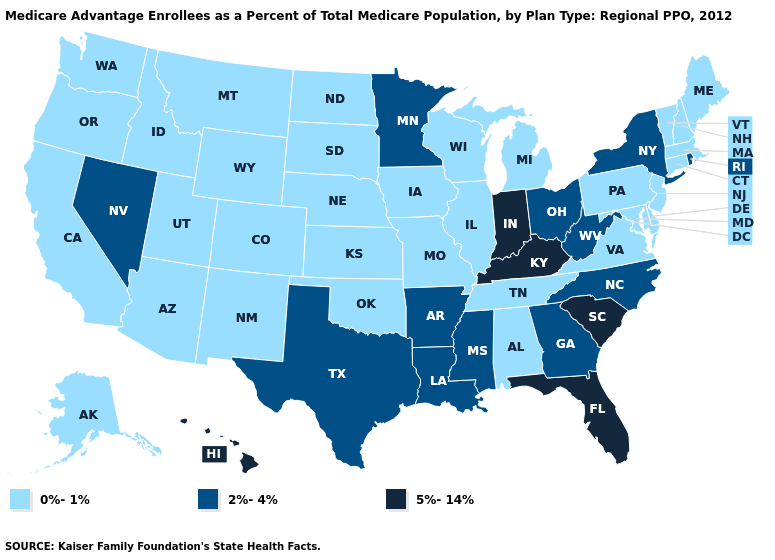Among the states that border Montana , which have the highest value?
Quick response, please. Idaho, North Dakota, South Dakota, Wyoming. Name the states that have a value in the range 5%-14%?
Concise answer only. Florida, Hawaii, Indiana, Kentucky, South Carolina. What is the value of Hawaii?
Concise answer only. 5%-14%. Name the states that have a value in the range 2%-4%?
Be succinct. Arkansas, Georgia, Louisiana, Minnesota, Mississippi, North Carolina, Nevada, New York, Ohio, Rhode Island, Texas, West Virginia. What is the value of Rhode Island?
Answer briefly. 2%-4%. Among the states that border Indiana , which have the lowest value?
Quick response, please. Illinois, Michigan. What is the value of Alaska?
Give a very brief answer. 0%-1%. What is the value of Connecticut?
Write a very short answer. 0%-1%. Among the states that border New Jersey , does New York have the lowest value?
Be succinct. No. Name the states that have a value in the range 0%-1%?
Concise answer only. Alaska, Alabama, Arizona, California, Colorado, Connecticut, Delaware, Iowa, Idaho, Illinois, Kansas, Massachusetts, Maryland, Maine, Michigan, Missouri, Montana, North Dakota, Nebraska, New Hampshire, New Jersey, New Mexico, Oklahoma, Oregon, Pennsylvania, South Dakota, Tennessee, Utah, Virginia, Vermont, Washington, Wisconsin, Wyoming. What is the value of Indiana?
Short answer required. 5%-14%. What is the value of South Carolina?
Be succinct. 5%-14%. Name the states that have a value in the range 2%-4%?
Be succinct. Arkansas, Georgia, Louisiana, Minnesota, Mississippi, North Carolina, Nevada, New York, Ohio, Rhode Island, Texas, West Virginia. How many symbols are there in the legend?
Quick response, please. 3. Does Delaware have the highest value in the South?
Be succinct. No. 